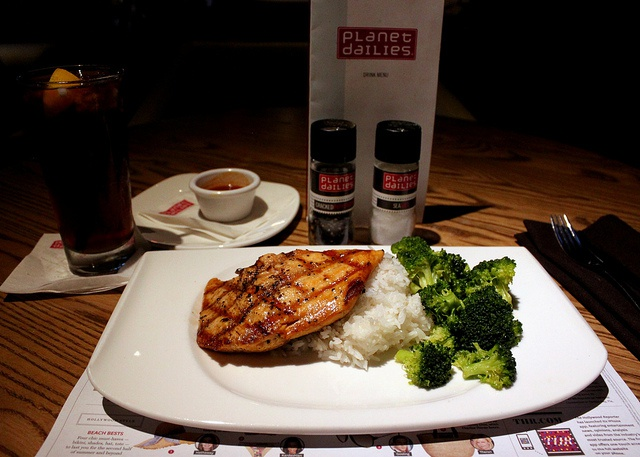Describe the objects in this image and their specific colors. I can see dining table in black, lightgray, maroon, and olive tones, cup in black, maroon, and olive tones, broccoli in black, olive, and darkgreen tones, bottle in black, maroon, and gray tones, and bottle in black, maroon, and gray tones in this image. 